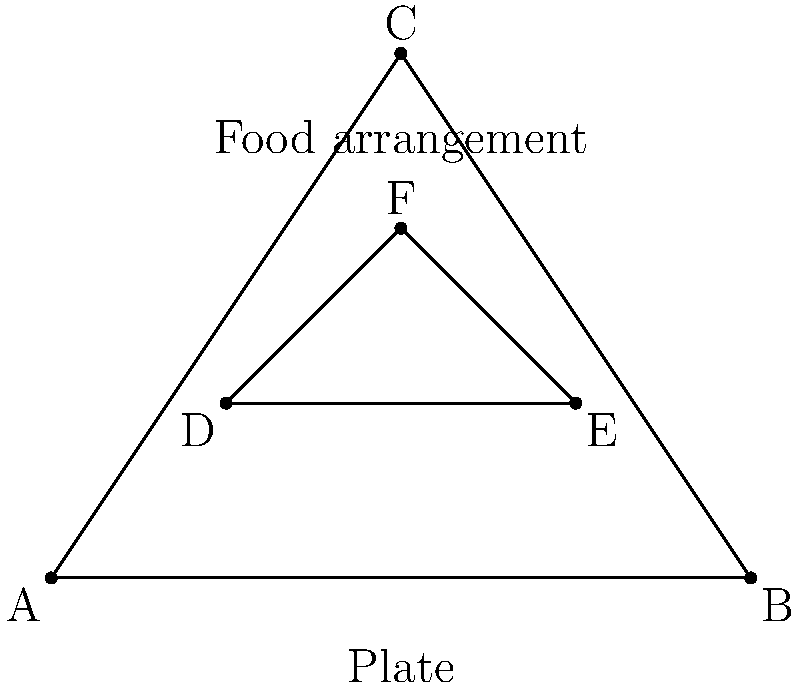In a haute cuisine plating arrangement, a triangular plate ABC contains a smaller triangular food arrangement DEF. If the plate's area is 6 square units and the food arrangement's area is 1 square unit, what is the ratio of the plate's perimeter to the food arrangement's perimeter? Let's approach this step-by-step:

1) For a triangle, if we know its area (A) and three sides (a, b, c), we can use Heron's formula:
   $$A = \sqrt{s(s-a)(s-b)(s-c)}$$
   where $s = \frac{a+b+c}{2}$ (semi-perimeter)

2) For the plate (ABC):
   Area = 6 sq units
   Let's assume it's an equilateral triangle for simplicity.
   If side length is x, then:
   $$6 = \frac{\sqrt{3}}{4}x^2$$
   $$x = \sqrt{\frac{24}{\sqrt{3}}} \approx 3.64$$

3) Perimeter of ABC = $3x \approx 10.92$

4) For the food arrangement (DEF):
   Area = 1 sq unit
   Again, assuming an equilateral triangle:
   $$1 = \frac{\sqrt{3}}{4}y^2$$
   $$y = \sqrt{\frac{4}{\sqrt{3}}} \approx 1.52$$

5) Perimeter of DEF = $3y \approx 4.56$

6) Ratio of perimeters = $\frac{10.92}{4.56} \approx 2.39$

7) This can be simplified to $\frac{12}{5}$ or 2.4
Answer: 2.4 : 1 